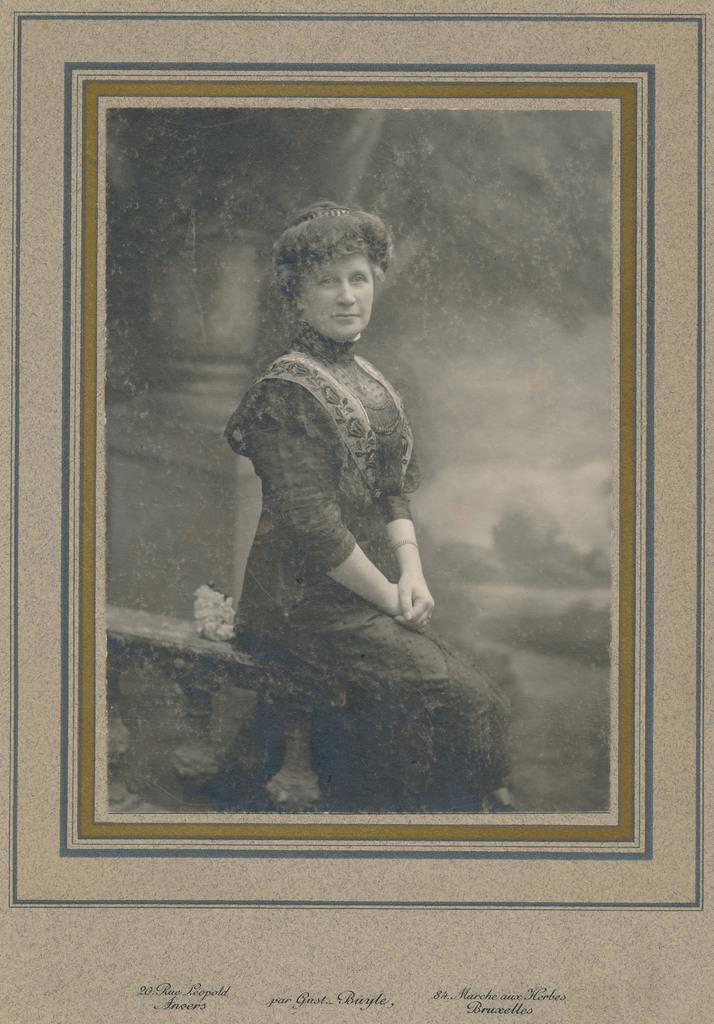What is the main object in the image? There is a frame in the image. What can be seen inside the frame? A lady is sitting on something within the frame. Is there any text present in the image? Yes, there is text written at the bottom of the image. What type of roof can be seen on the train in the image? There is no train or roof present in the image. How does the lady solve the arithmetic problem in the image? There is no arithmetic problem present in the image. 